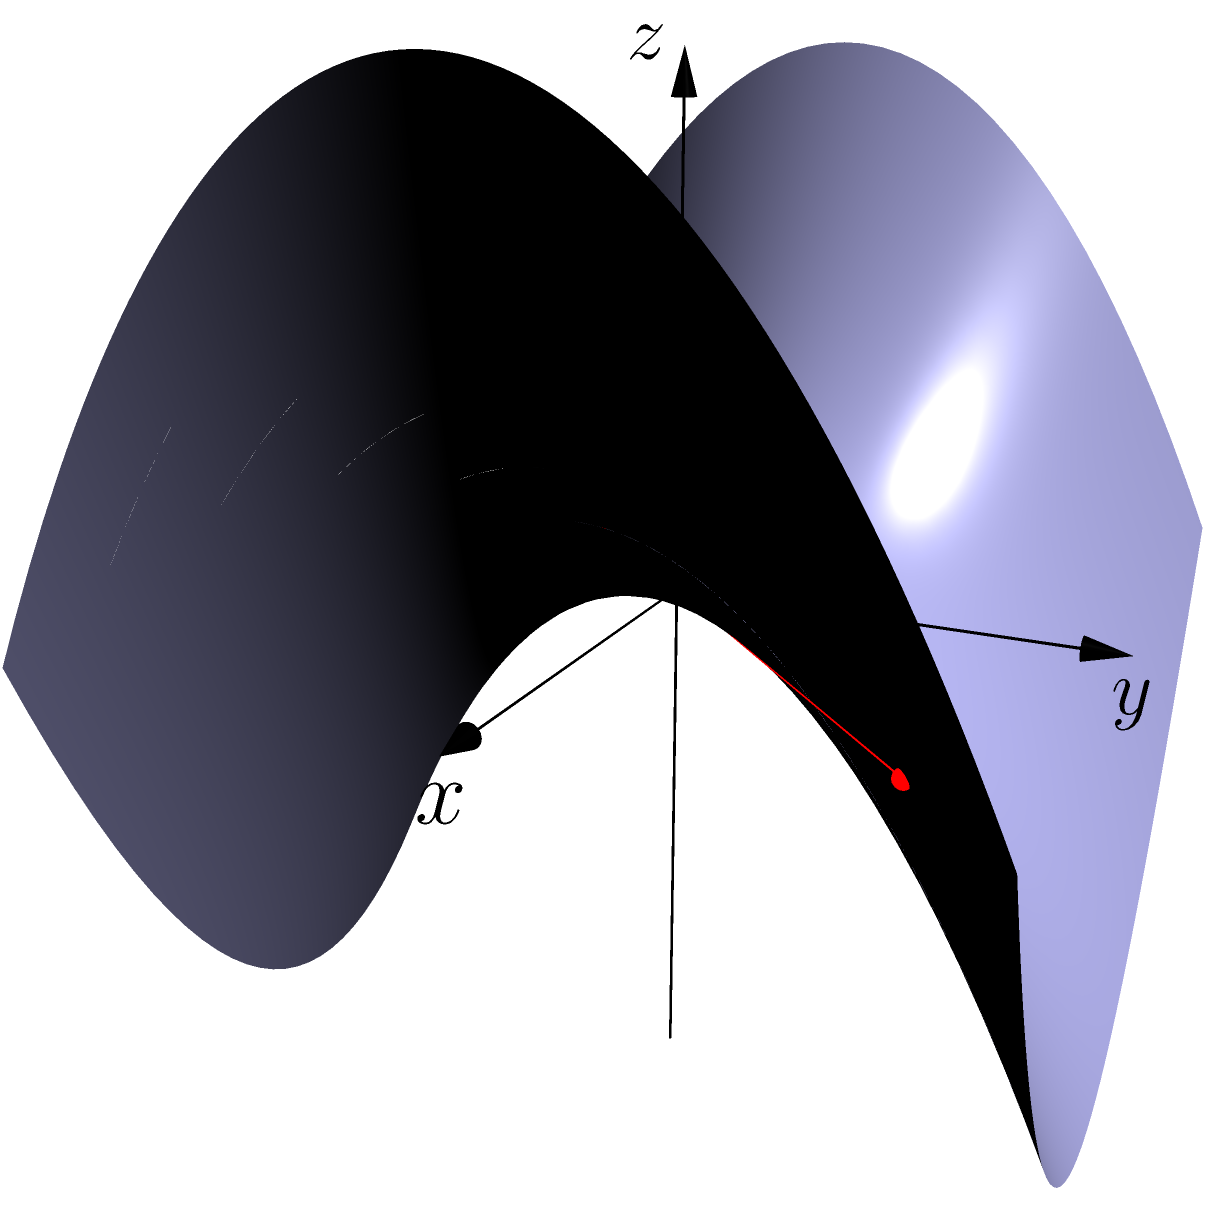In the context of non-Euclidean geometry, consider a saddle-shaped surface represented by the equation $z = x^2 - y^2$. Two points, A and B, are located at (-1.5, -1.5, 0.5) and (1.5, 1.5, 0.5) respectively. As a business owner who often needs to optimize routes for efficient resource allocation, how would you describe the shortest path between these two points on this surface compared to the straight line shown in red? To understand the shortest path between two points on a saddle-shaped surface, we need to consider the following steps:

1. Surface characteristics: The surface is described by $z = x^2 - y^2$, which is a hyperbolic paraboloid or saddle shape.

2. Geodesics: In non-Euclidean geometry, the shortest path between two points on a curved surface is called a geodesic. Geodesics on a saddle surface are not straight lines when viewed in 3D space.

3. Straight line vs. geodesic: The red line in the diagram represents the straight line path between A and B in 3D space. However, this is not the shortest path on the surface itself.

4. Path on the surface: The actual shortest path (geodesic) would curve away from the straight line, following the contours of the saddle shape.

5. Intuitive understanding: Imagine "unrolling" the surface onto a plane. The shortest path would appear straighter in this unrolled state, but curved when projected back onto the 3D surface.

6. Mathematical complexity: Calculating the exact geodesic requires solving differential equations and is beyond the scope of this explanation.

7. Business analogy: In business, the "shortest path" between two goals might not always be a straight line. Sometimes, adapting to the "shape" of the market or industry (like following the saddle surface) can lead to more efficient outcomes.
Answer: The shortest path curves away from the straight line, following the saddle's contours. 